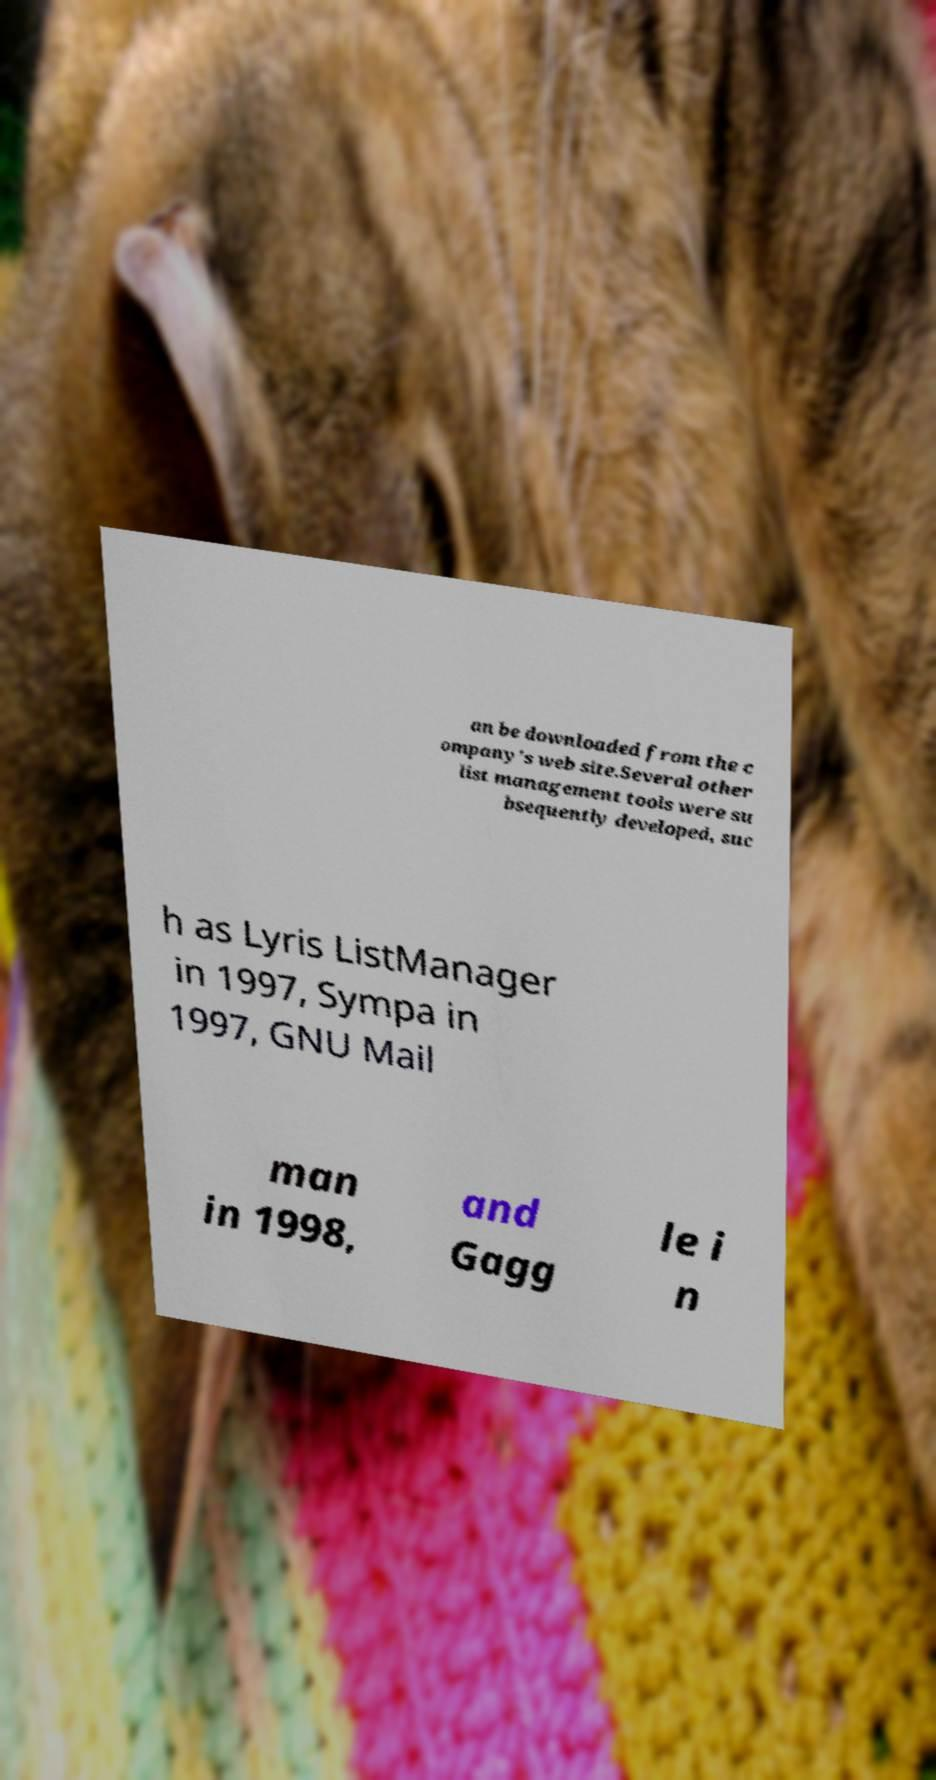Can you read and provide the text displayed in the image?This photo seems to have some interesting text. Can you extract and type it out for me? an be downloaded from the c ompany's web site.Several other list management tools were su bsequently developed, suc h as Lyris ListManager in 1997, Sympa in 1997, GNU Mail man in 1998, and Gagg le i n 